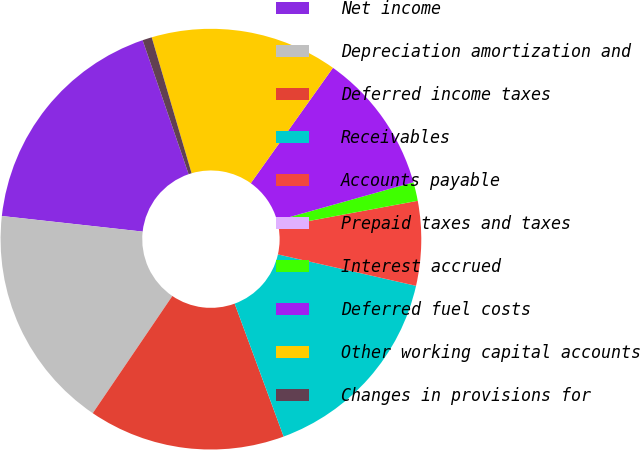<chart> <loc_0><loc_0><loc_500><loc_500><pie_chart><fcel>Net income<fcel>Depreciation amortization and<fcel>Deferred income taxes<fcel>Receivables<fcel>Accounts payable<fcel>Prepaid taxes and taxes<fcel>Interest accrued<fcel>Deferred fuel costs<fcel>Other working capital accounts<fcel>Changes in provisions for<nl><fcel>17.98%<fcel>17.26%<fcel>15.11%<fcel>15.82%<fcel>6.48%<fcel>0.0%<fcel>1.44%<fcel>10.79%<fcel>14.39%<fcel>0.72%<nl></chart> 